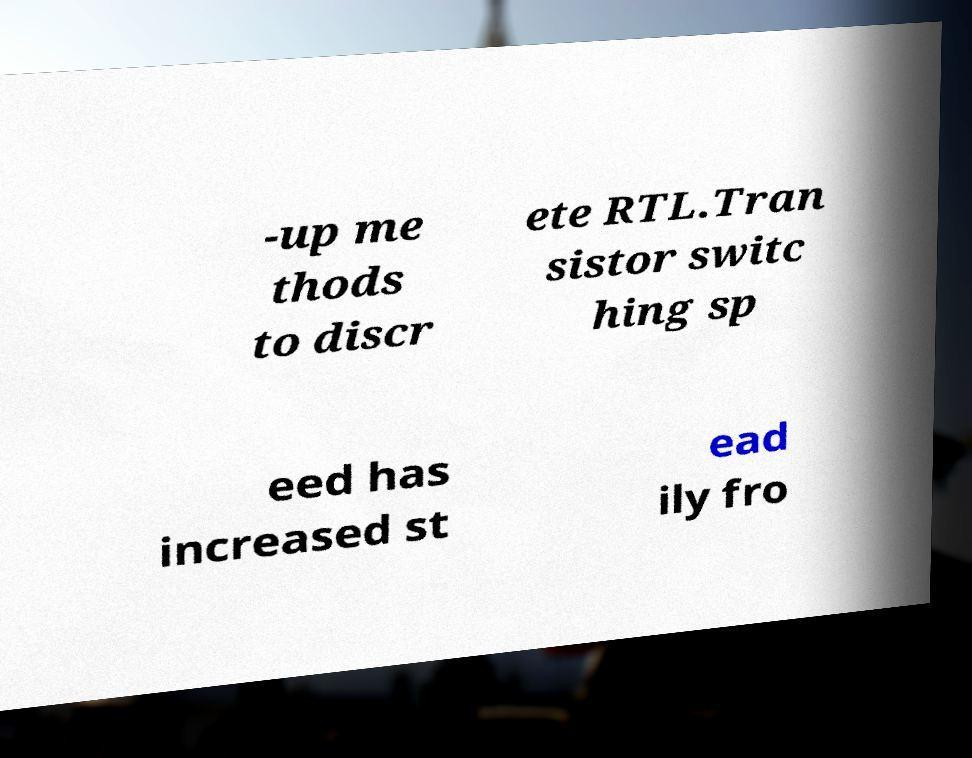Can you accurately transcribe the text from the provided image for me? -up me thods to discr ete RTL.Tran sistor switc hing sp eed has increased st ead ily fro 